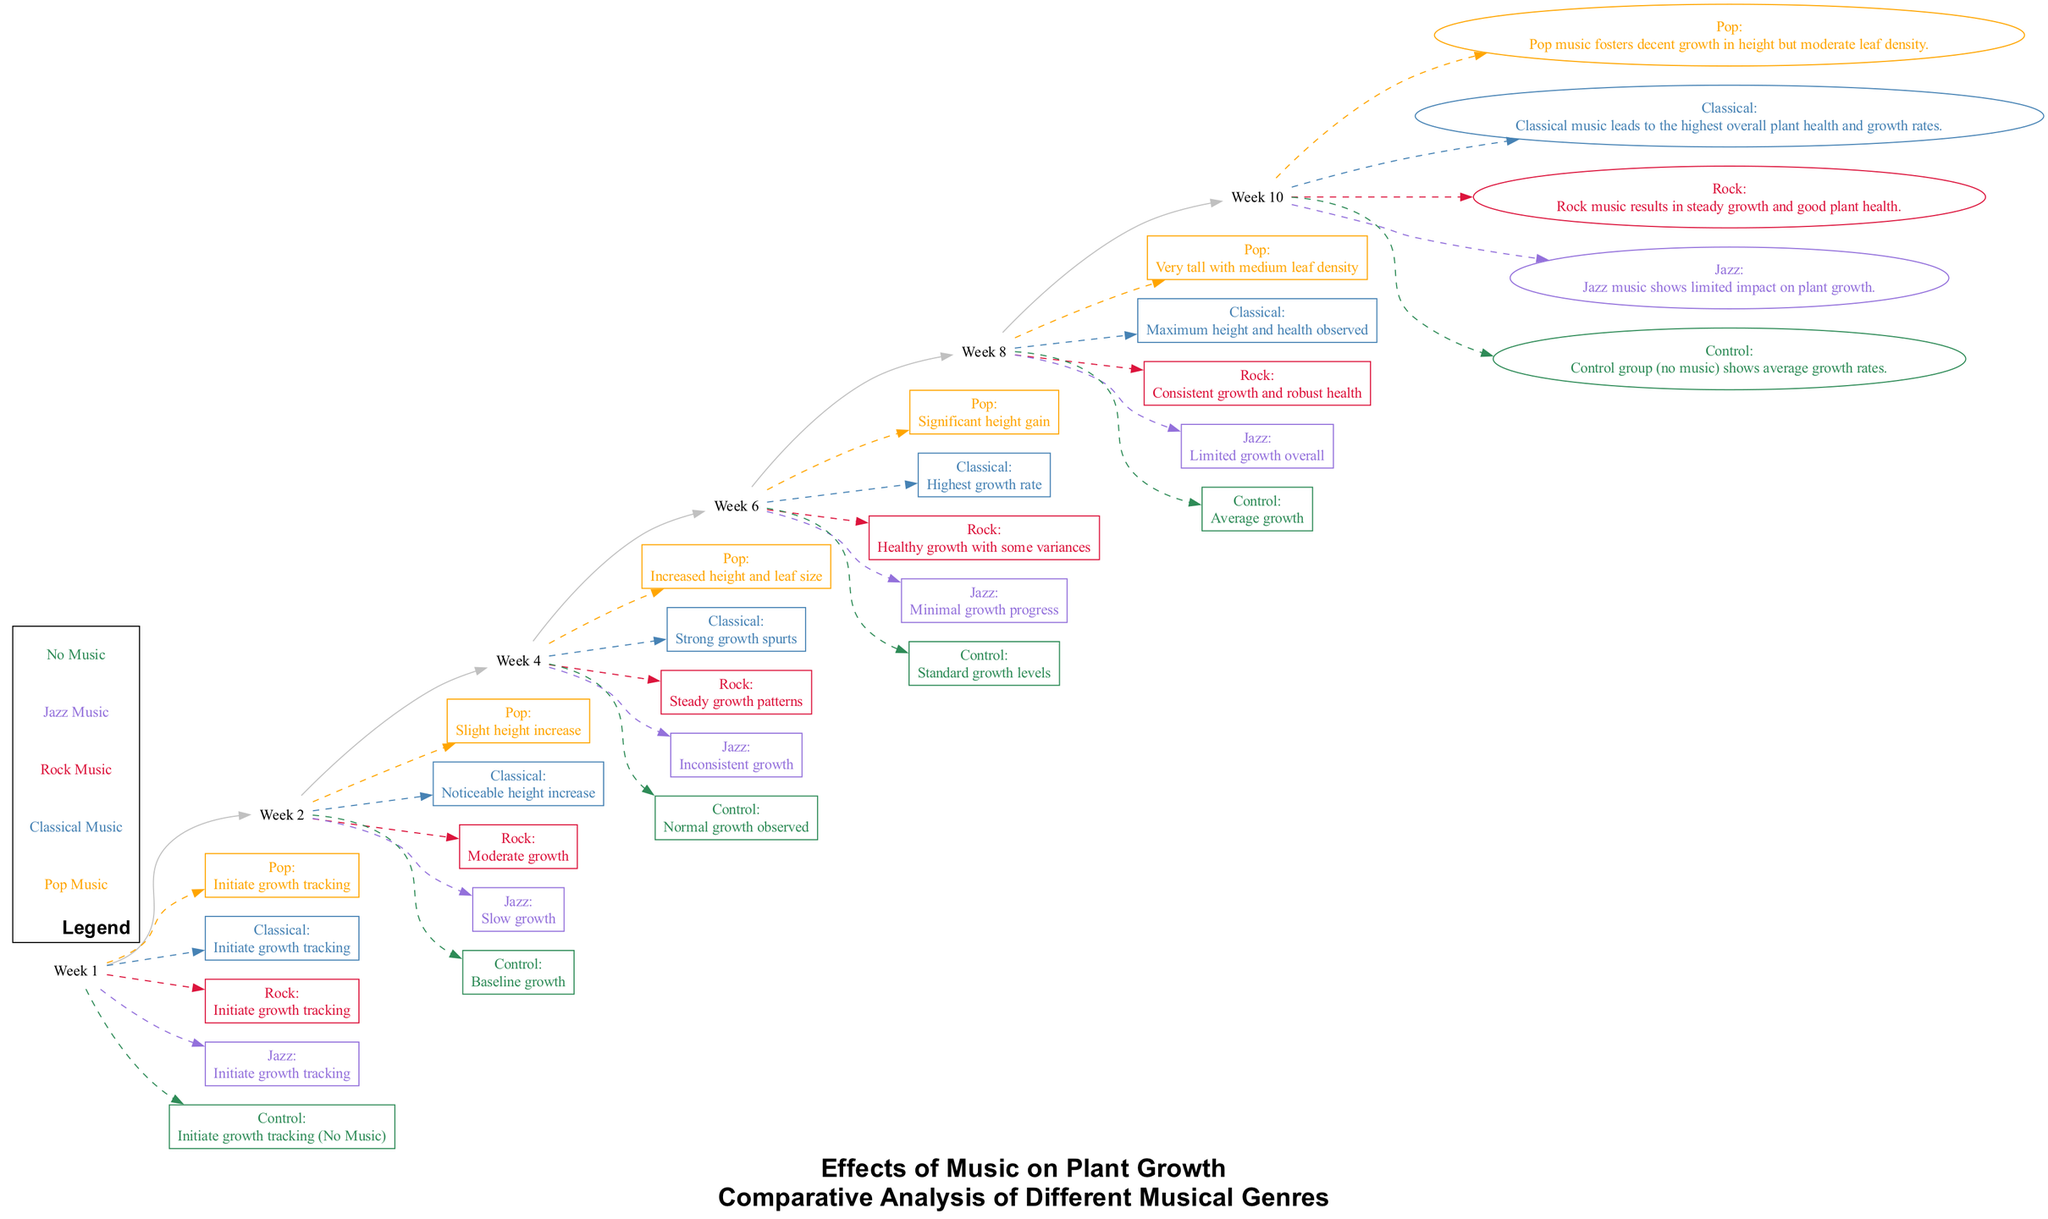What was the observed growth for Jazz music by Week 2? In Week 2, the annotation for Jazz indicates "Slow growth." This provides a descriptive metric of how Jazz music affected plant growth at that specific time.
Answer: Slow growth Which musical genre showed the highest growth rate by Week 6? By Week 6, the annotation for Classical music states "Highest growth rate," indicating it outperformed other genres in promoting plant growth up to that week.
Answer: Highest growth rate How many musical genres are compared in this study? The diagram includes five genres: Pop, Classical, Rock, Jazz, and Control (No Music). Counting each distinct genre shows that there are five in total.
Answer: Five What conclusion is drawn about Pop music in Week 10? In Week 10, the conclusion for Pop states, "Pop music fosters decent growth in height but moderate leaf density," summarizing the findings related to Pop music's impact on plant growth.
Answer: Decent growth in height but moderate leaf density Which genre had limited impact on plant growth overall? The annotation in the conclusion for Jazz reads, "Jazz music shows limited impact on plant growth," indicating its overall weak performance in the study.
Answer: Limited impact on plant growth What was the plant growth status in the Control group by Week 8? The annotation for the Control group in Week 8 states, "Average growth," which gives information about the growth level without any musical influence.
Answer: Average growth What were the characteristics of plants exposed to Classical music by Week 4? The details in Week 4 indicate that plants exposed to Classical music had "Strong growth spurts," showcasing a significant positive response to this genre.
Answer: Strong growth spurts Which genre was associated with inconsistent growth patterns by Week 6? The annotation for Jazz music in Week 6 specifies "Minimal growth progress," which contrasts with the other genres, indicating instability in its growth performance.
Answer: Inconsistent growth patterns What was the height of Pop music-influenced plants by Week 8? The Week 8 annotation for Pop music states "Very tall with medium leaf density," providing a clear statement regarding the size and health of those plants.
Answer: Very tall with medium leaf density 